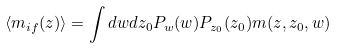<formula> <loc_0><loc_0><loc_500><loc_500>\langle m _ { i f } ( z ) \rangle = \int d w d z _ { 0 } P _ { w } ( w ) P _ { z _ { 0 } } ( z _ { 0 } ) m ( z , z _ { 0 } , w )</formula> 